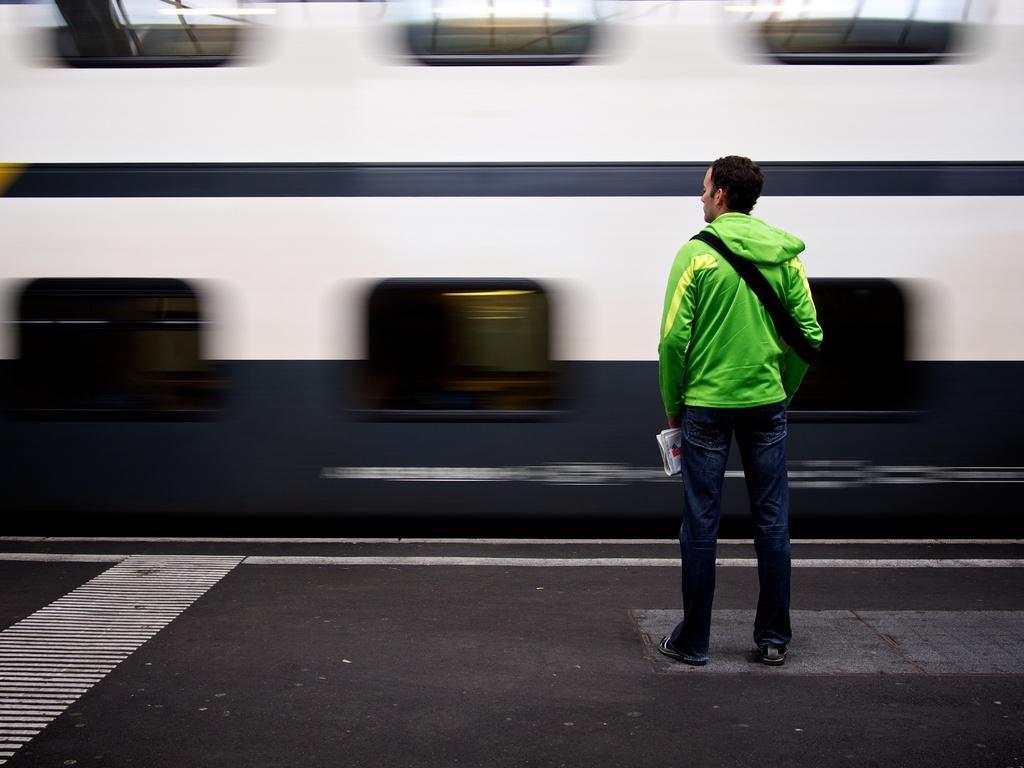Can you describe this image briefly? This picture is clicked outside. On the right we can see a person holding an object and standing on the ground. In the background we can see a vehicle seems to be the train which seems to be running on the railway track. 